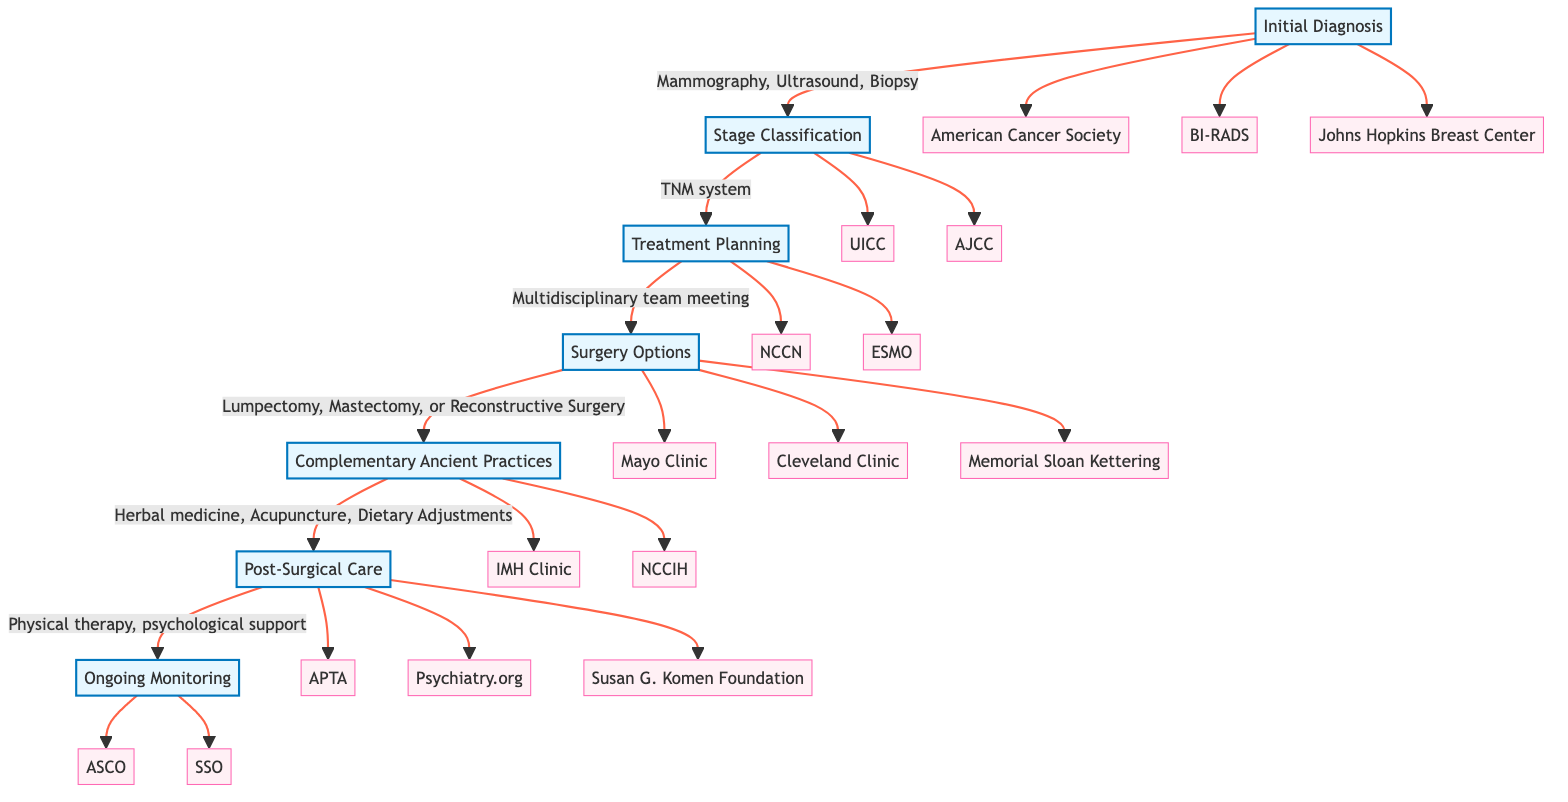What is the first step in the pathway? The diagram shows that the first step is "Initial Diagnosis." This is indicated by the flow starting from the node labeled "Initial Diagnosis."
Answer: Initial Diagnosis How many treatment options are listed under Surgery Options? Under the "Surgery Options" node, there are three listed treatment options: Lumpectomy, Mastectomy, and Reconstructive Surgery. Each is explicitly mentioned as part of that step.
Answer: 3 Which organization is associated with the Stage Classification step? The "Stage Classification" step is linked to two entities: the Union for International Cancer Control (UICC) and the American Joint Committee on Cancer (AJCC). Therefore, either one can be recognized as associated with this step.
Answer: UICC or AJCC What type of support is provided in the Post-Surgical Care step? The "Post-Surgical Care" node indicates that the support provided includes physical therapy and psychological support, clearly stated in the description within that node.
Answer: Physical therapy and psychological support What comes after Complementary Ancient Practices? After the "Complementary Ancient Practices" step, the next step in the diagram is "Post-Surgical Care." This can be deduced by tracing the flow from the Complementary Ancient Practices node to Post-Surgical Care node.
Answer: Post-Surgical Care Which clinical entity is involved in ongoing monitoring? The "Ongoing Monitoring" step includes the following clinical entities: American Society of Clinical Oncology (ASCO) and Society of Surgical Oncology (SSO). Therefore, either of these entities can be noted as involved in ongoing monitoring.
Answer: ASCO or SSO What method is mentioned for diagnosis in the Initial Diagnosis step? The method for diagnosis mentioned in the "Initial Diagnosis" step includes Mammography, Ultrasound, and Biopsy. Each of these methods is listed directly in the description of that step.
Answer: Mammography, Ultrasound, and Biopsy How many steps are there in total in this clinical pathway? Counting from the "Initial Diagnosis" through to "Ongoing Monitoring," there are a total of seven distinct steps in this clinical pathway. This can be confirmed by counting each labeled step node in the diagram.
Answer: 7 What is the purpose of treatment planning? The "Treatment Planning" step involves a multidisciplinary team meeting to discuss treatment options. This purpose is clearly expressed in the description associated with that step.
Answer: Multidisciplinary team meeting to discuss treatment options 